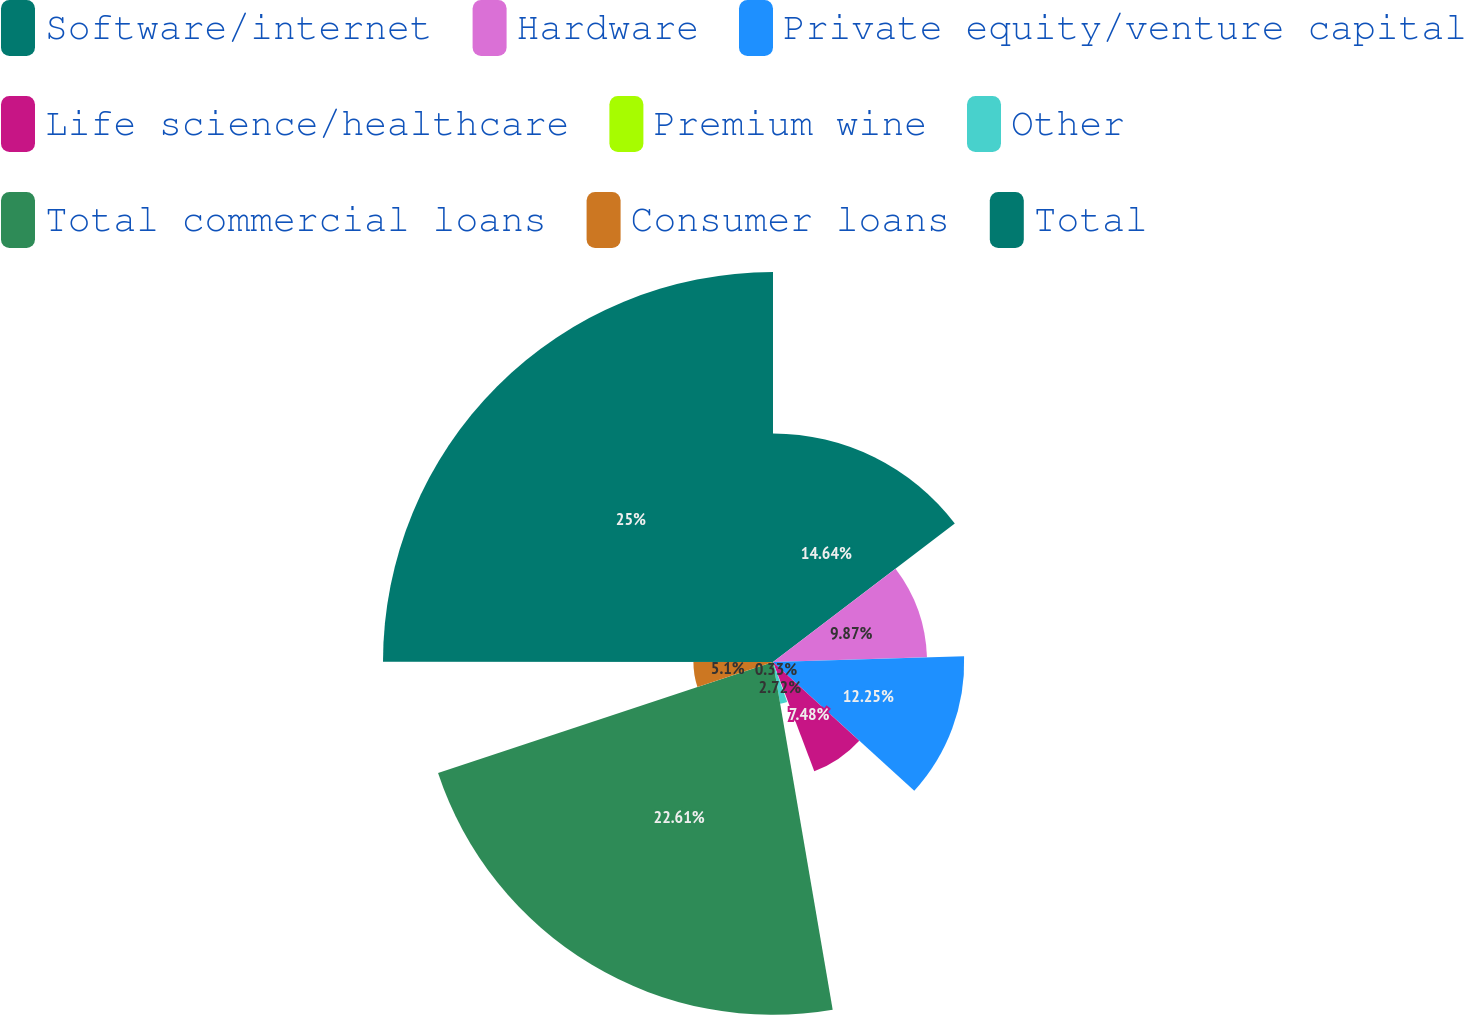Convert chart to OTSL. <chart><loc_0><loc_0><loc_500><loc_500><pie_chart><fcel>Software/internet<fcel>Hardware<fcel>Private equity/venture capital<fcel>Life science/healthcare<fcel>Premium wine<fcel>Other<fcel>Total commercial loans<fcel>Consumer loans<fcel>Total<nl><fcel>14.64%<fcel>9.87%<fcel>12.25%<fcel>7.48%<fcel>0.33%<fcel>2.72%<fcel>22.61%<fcel>5.1%<fcel>24.99%<nl></chart> 